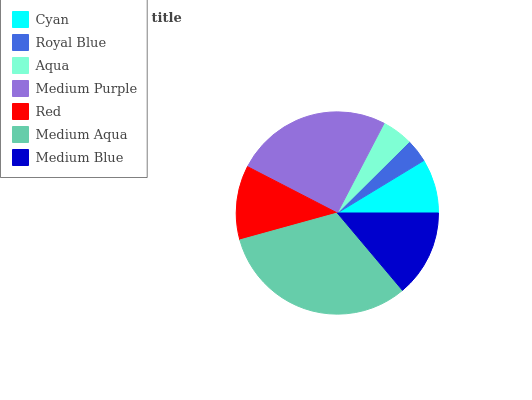Is Royal Blue the minimum?
Answer yes or no. Yes. Is Medium Aqua the maximum?
Answer yes or no. Yes. Is Aqua the minimum?
Answer yes or no. No. Is Aqua the maximum?
Answer yes or no. No. Is Aqua greater than Royal Blue?
Answer yes or no. Yes. Is Royal Blue less than Aqua?
Answer yes or no. Yes. Is Royal Blue greater than Aqua?
Answer yes or no. No. Is Aqua less than Royal Blue?
Answer yes or no. No. Is Red the high median?
Answer yes or no. Yes. Is Red the low median?
Answer yes or no. Yes. Is Medium Aqua the high median?
Answer yes or no. No. Is Medium Blue the low median?
Answer yes or no. No. 